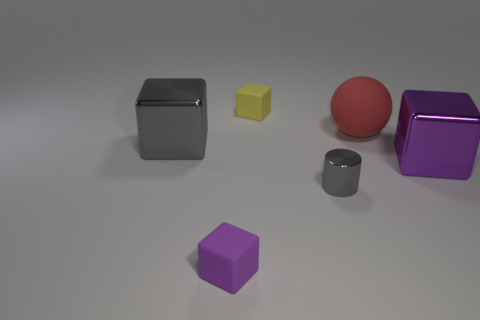Add 4 purple things. How many objects exist? 10 Subtract all blocks. How many objects are left? 2 Add 1 tiny shiny objects. How many tiny shiny objects exist? 2 Subtract 0 blue cylinders. How many objects are left? 6 Subtract all purple blocks. Subtract all small gray cylinders. How many objects are left? 3 Add 1 small metallic things. How many small metallic things are left? 2 